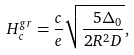<formula> <loc_0><loc_0><loc_500><loc_500>H _ { c } ^ { g r } = { \frac { c } { e } } \sqrt { \frac { { \ 5 \Delta _ { 0 } } } { { 2 R ^ { 2 } D } } } ,</formula> 